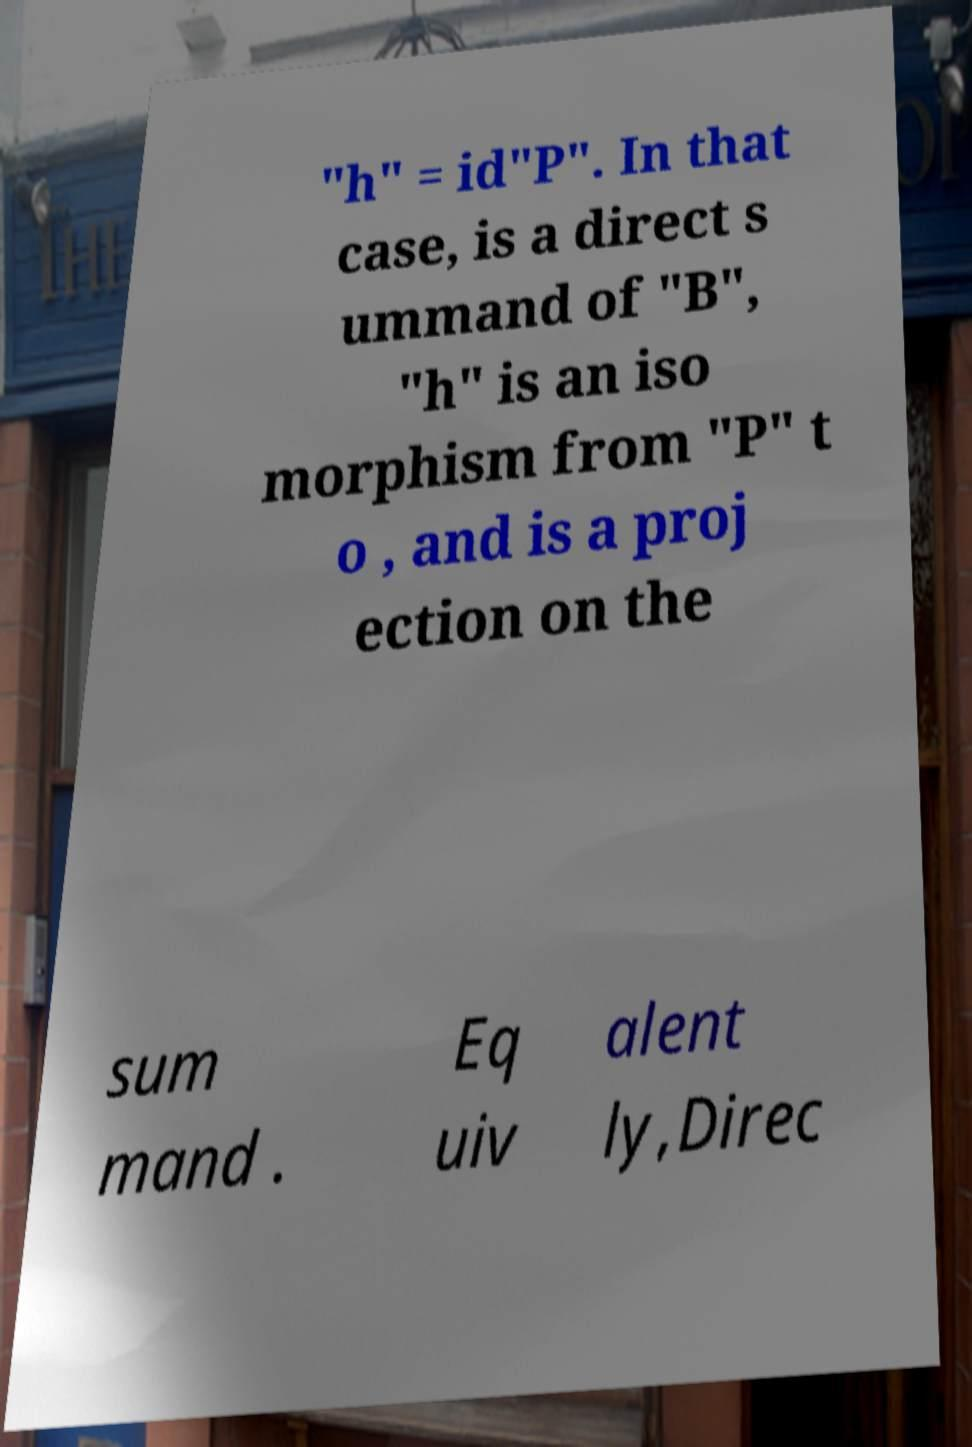For documentation purposes, I need the text within this image transcribed. Could you provide that? "h" = id"P". In that case, is a direct s ummand of "B", "h" is an iso morphism from "P" t o , and is a proj ection on the sum mand . Eq uiv alent ly,Direc 